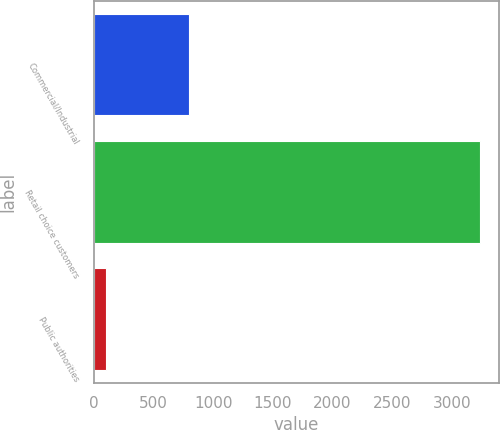<chart> <loc_0><loc_0><loc_500><loc_500><bar_chart><fcel>Commercial/Industrial<fcel>Retail choice customers<fcel>Public authorities<nl><fcel>802<fcel>3237<fcel>100<nl></chart> 